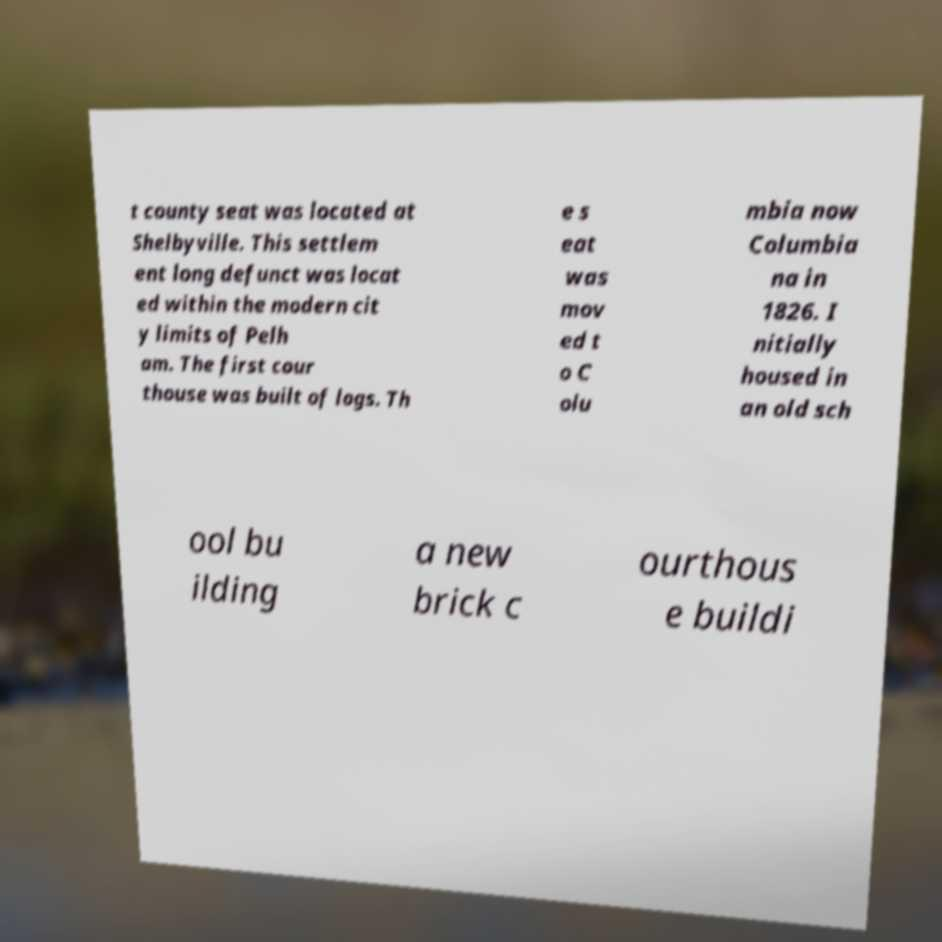Could you assist in decoding the text presented in this image and type it out clearly? t county seat was located at Shelbyville. This settlem ent long defunct was locat ed within the modern cit y limits of Pelh am. The first cour thouse was built of logs. Th e s eat was mov ed t o C olu mbia now Columbia na in 1826. I nitially housed in an old sch ool bu ilding a new brick c ourthous e buildi 